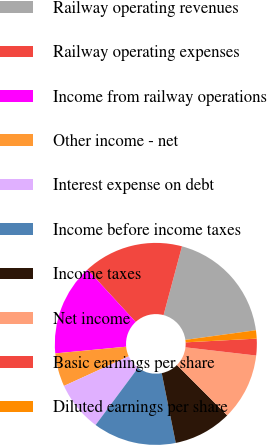Convert chart. <chart><loc_0><loc_0><loc_500><loc_500><pie_chart><fcel>Railway operating revenues<fcel>Railway operating expenses<fcel>Income from railway operations<fcel>Other income - net<fcel>Interest expense on debt<fcel>Income before income taxes<fcel>Income taxes<fcel>Net income<fcel>Basic earnings per share<fcel>Diluted earnings per share<nl><fcel>18.67%<fcel>16.0%<fcel>14.67%<fcel>5.33%<fcel>8.0%<fcel>13.33%<fcel>9.33%<fcel>10.67%<fcel>2.67%<fcel>1.33%<nl></chart> 